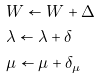Convert formula to latex. <formula><loc_0><loc_0><loc_500><loc_500>& W \leftarrow W + \Delta \\ & \lambda \leftarrow \lambda + \delta \\ & \mu \leftarrow \mu + \delta _ { \mu }</formula> 